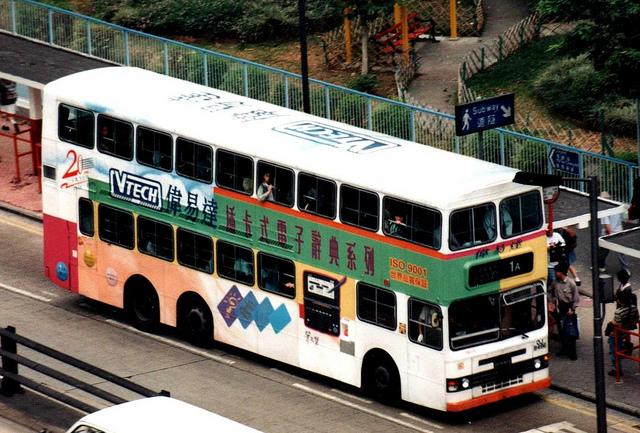On what side of the bus should they go if they want to take the metro?

Choices:
A) left
B) right
C) back
D) front left 